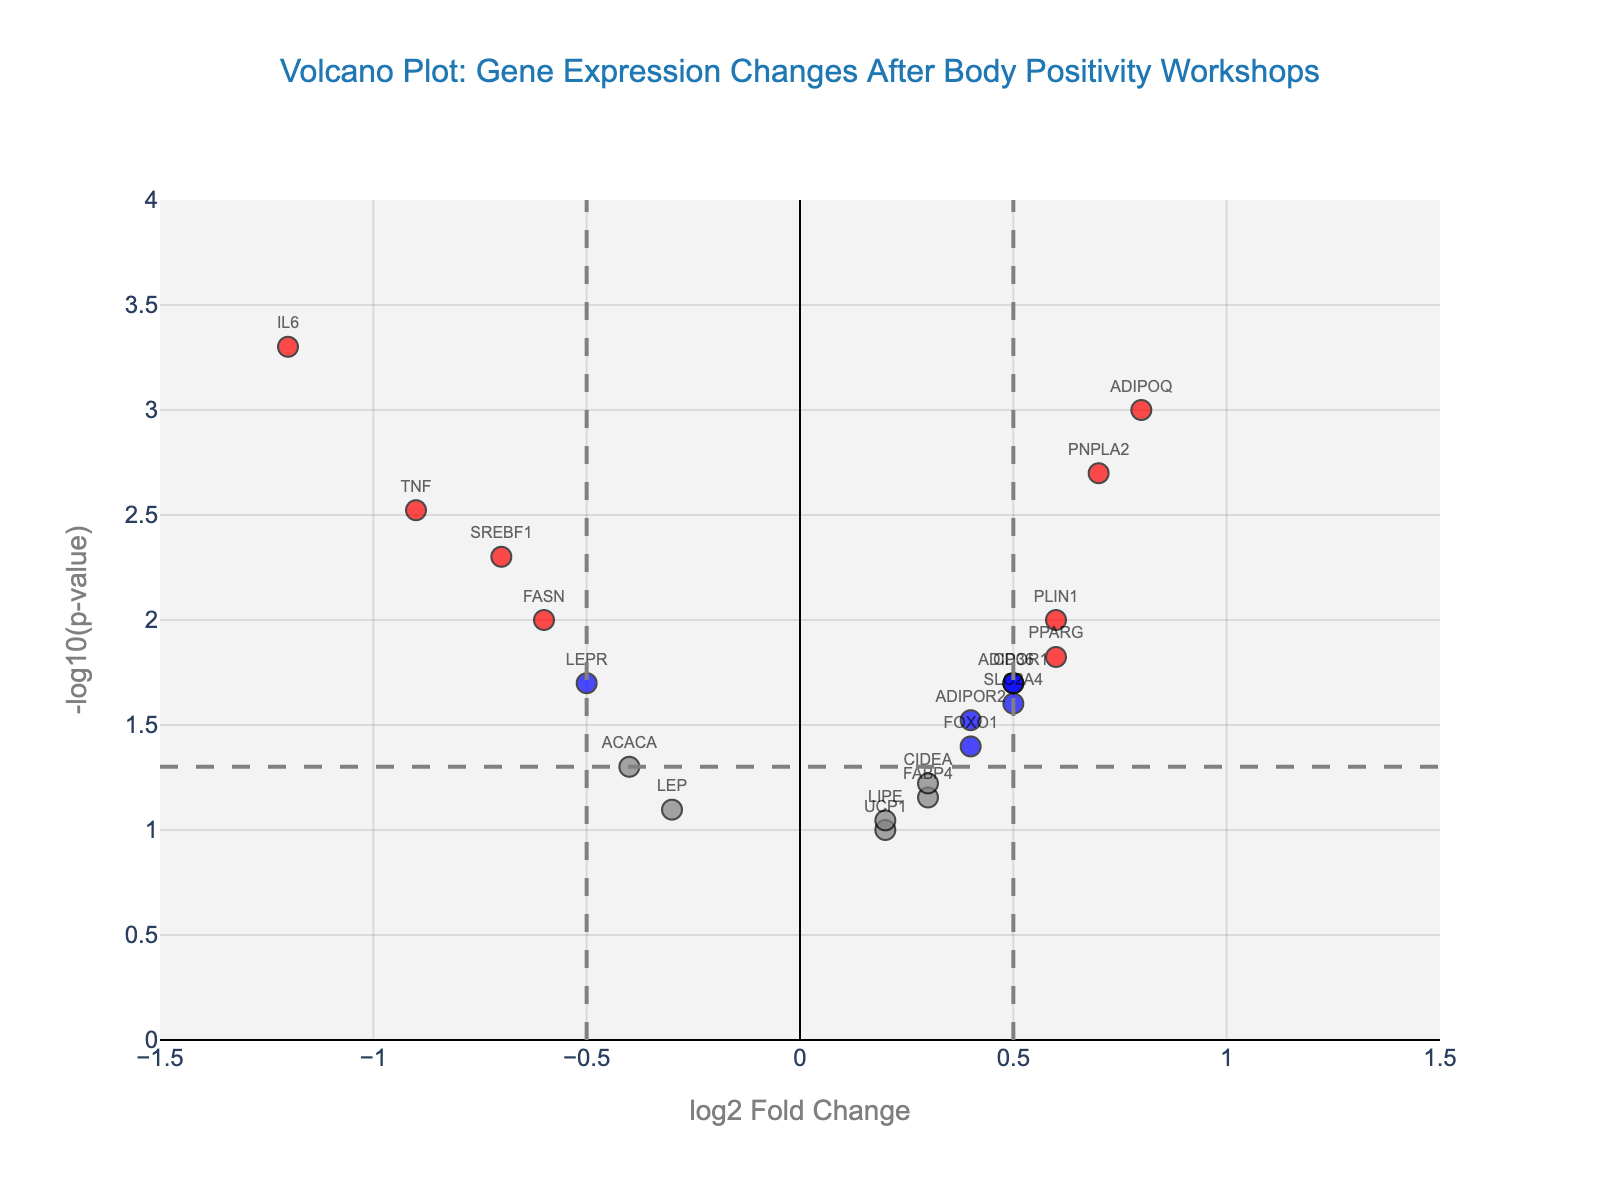What's the title of the figure? The title is usually displayed at the top of the plot. Here, it reads "Volcano Plot: Gene Expression Changes After Body Positivity Workshops".
Answer: Volcano Plot: Gene Expression Changes After Body Positivity Workshops What do the x-axis and y-axis represent? The x-axis represents the log2 Fold Change, and the y-axis represents the -log10(p-value). This means the x-axis shows changes in gene expression levels, while the y-axis shows the significance of those changes.
Answer: log2 Fold Change and -log10(p-value) How many data points are annotated with gene names? Each annotated data point on the plot has a gene name displayed beside it. By counting the visible gene names, we find there are 19 annotated data points.
Answer: 19 Which gene has the highest log2 Fold Change? By looking at the x-axis values (log2 Fold Change), the gene with the highest positive value on this axis is ADIPOQ with a value of 0.8.
Answer: ADIPOQ Which gene has the smallest p-value? The p-value is inversely related to the y-axis value, so the gene with the highest -log10(p-value) has the smallest p-value. In this case, it is IL6 with a -log10(p-value) of approximately 3.30.
Answer: IL6 How many genes have a log2 Fold Change greater than 0 and significant p-values? Look for points to the right of 0 on the x-axis that are above the horizontal line at -log10(p-value) = 1.3. The genes fulfilling this condition are ADIPOQ, PPARG, PNPLA2, PLIN1, and CD36. This is a total of 5 genes.
Answer: 5 Identify a gene that has a negative log2 Fold Change but is considered significant. Points to the left of 0 on the x-axis that are above the horizontal line at -log10(p-value) = 1.3 are considered negative log2 Fold Change and significant. One example is IL6.
Answer: IL6 Which color on the plot represents genes with significant p-values but low fold changes? Referring to the color definitions, blue indicates genes where the absolute log2 Fold Change is ≤ 0.5 and the p-value is < 0.05.
Answer: Blue What are the coordinates (log2 Fold Change and -log10(p-value)) of the gene FASN? Locate FASN on the plot and read its associated values on both axes. The log2 Fold Change is -0.6, and the -log10(p-value) is approximately 2.00.
Answer: (-0.6, 2.00) Name two genes with significant log2 Fold Changes and significant p-values. Significant log2 Fold Changes are those with absolute values > 0.5, and significant p-values are those where -log10(p-value) > 1.3. Examples are ADIPOQ and IL6.
Answer: ADIPOQ and IL6 